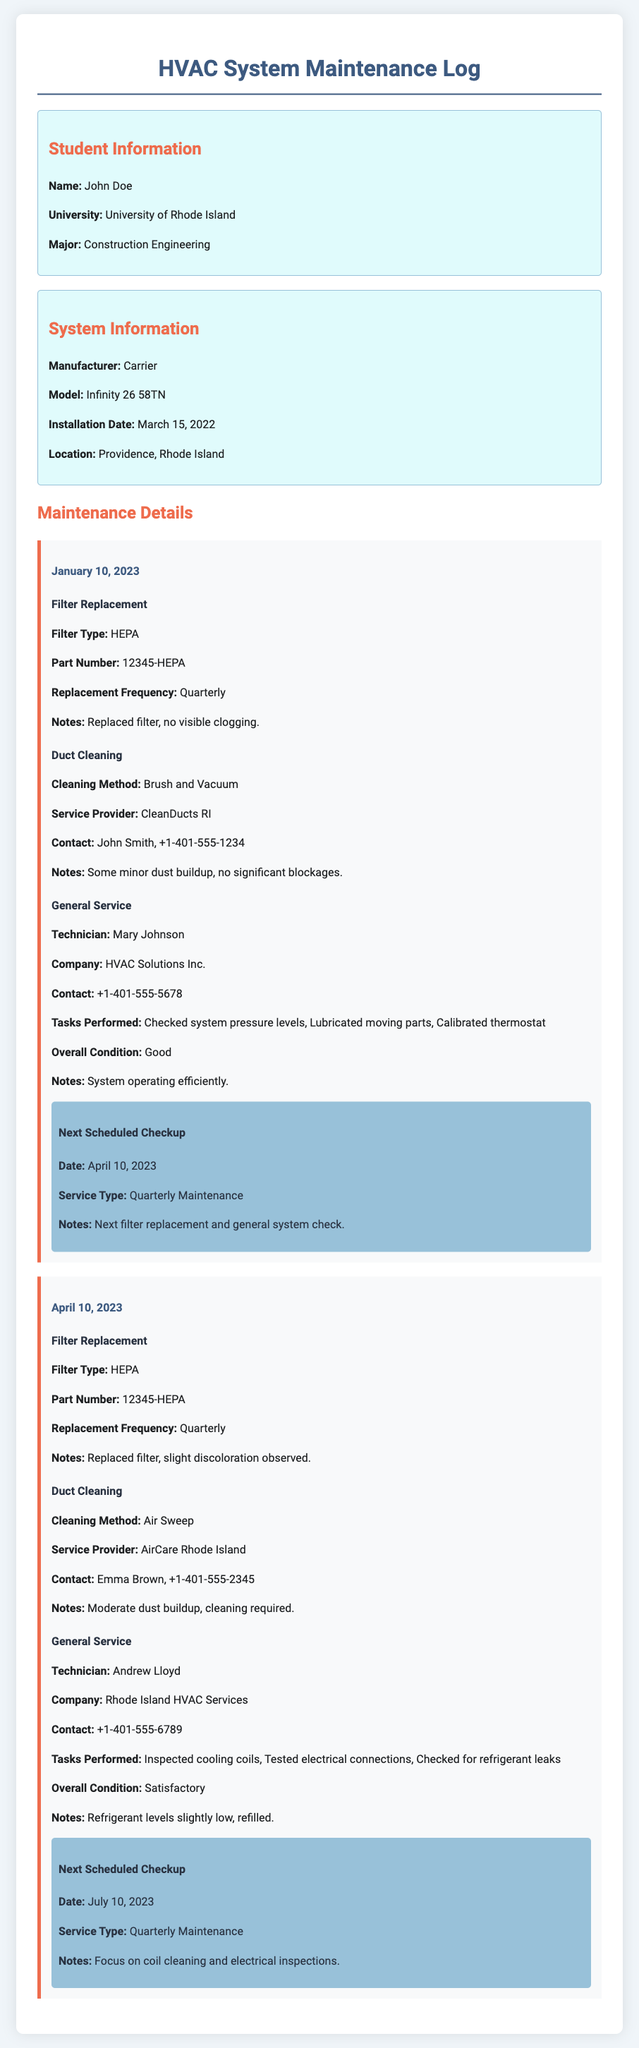What is the name of the student? The name of the student is provided in the "Student Information" section of the document.
Answer: John Doe What is the installation date of the HVAC system? The installation date can be found under "System Information."
Answer: March 15, 2022 What type of filter was replaced on January 10, 2023? The document specifies the type of filter replaced during a maintenance entry.
Answer: HEPA Who performed the duct cleaning on April 10, 2023? This information is noted in the maintenance entry for duct cleaning.
Answer: AirCare Rhode Island When is the next scheduled checkup after April 10, 2023? The next checkup date is listed in the maintenance details following the April entry.
Answer: July 10, 2023 What was observed during the filter replacement in January 2023? The notes from the filter replacement provide information about its condition.
Answer: No visible clogging What tasks were performed during the general service on April 10, 2023? The tasks performed are detailed in the service section for that date.
Answer: Inspected cooling coils, Tested electrical connections, Checked for refrigerant leaks What was the overall condition of the system as noted in the April maintenance? This evaluation is part of the general service details provided.
Answer: Satisfactory What method was used for duct cleaning on January 10, 2023? This information is included under the duct cleaning service entry for the date.
Answer: Brush and Vacuum 